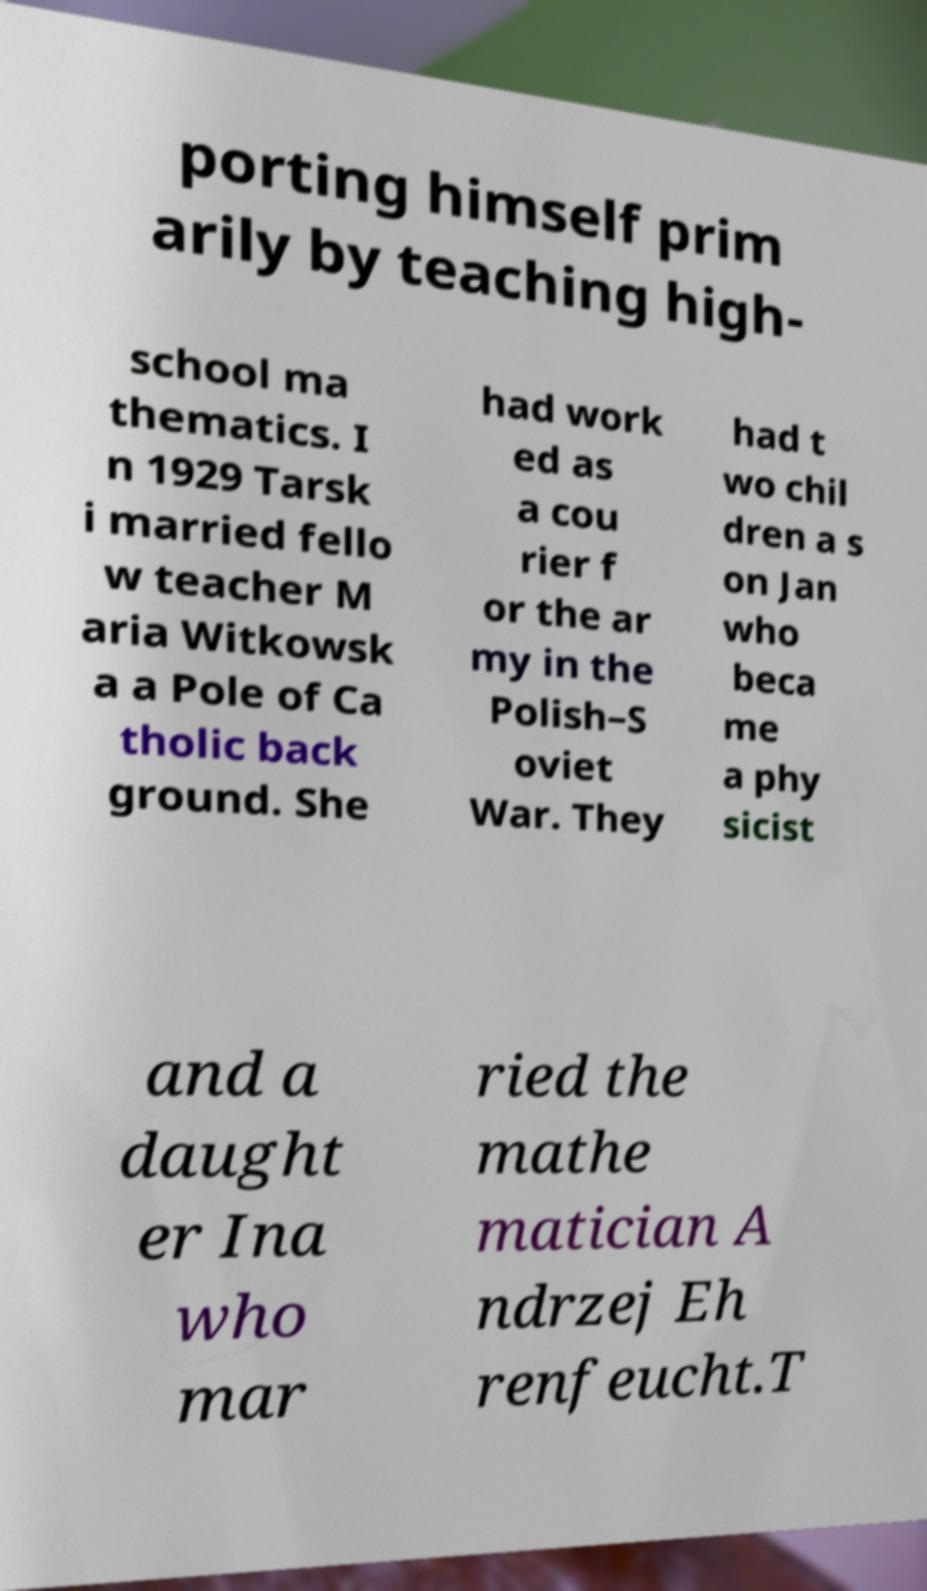Please read and relay the text visible in this image. What does it say? porting himself prim arily by teaching high- school ma thematics. I n 1929 Tarsk i married fello w teacher M aria Witkowsk a a Pole of Ca tholic back ground. She had work ed as a cou rier f or the ar my in the Polish–S oviet War. They had t wo chil dren a s on Jan who beca me a phy sicist and a daught er Ina who mar ried the mathe matician A ndrzej Eh renfeucht.T 